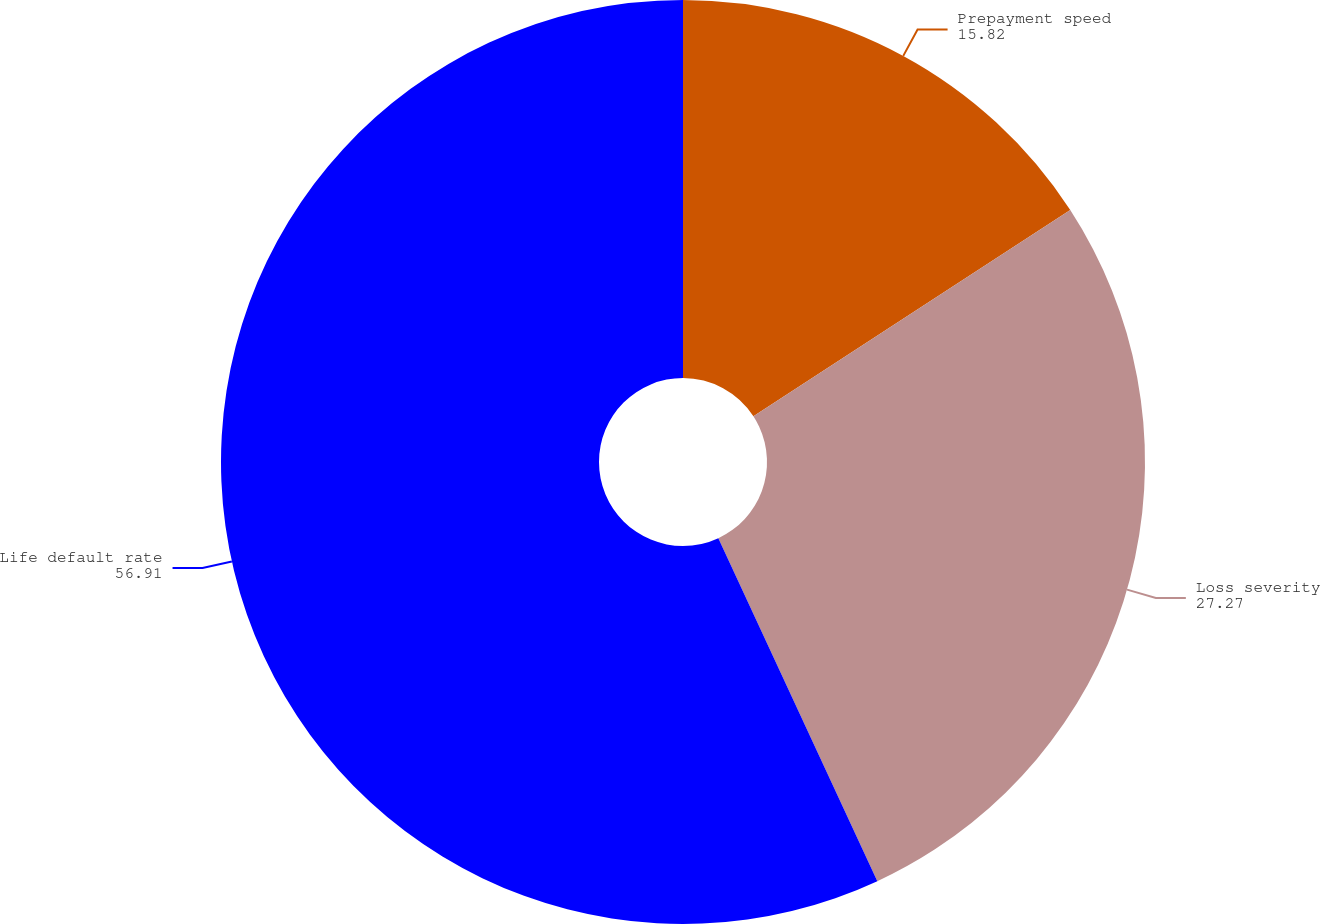<chart> <loc_0><loc_0><loc_500><loc_500><pie_chart><fcel>Prepayment speed<fcel>Loss severity<fcel>Life default rate<nl><fcel>15.82%<fcel>27.27%<fcel>56.91%<nl></chart> 